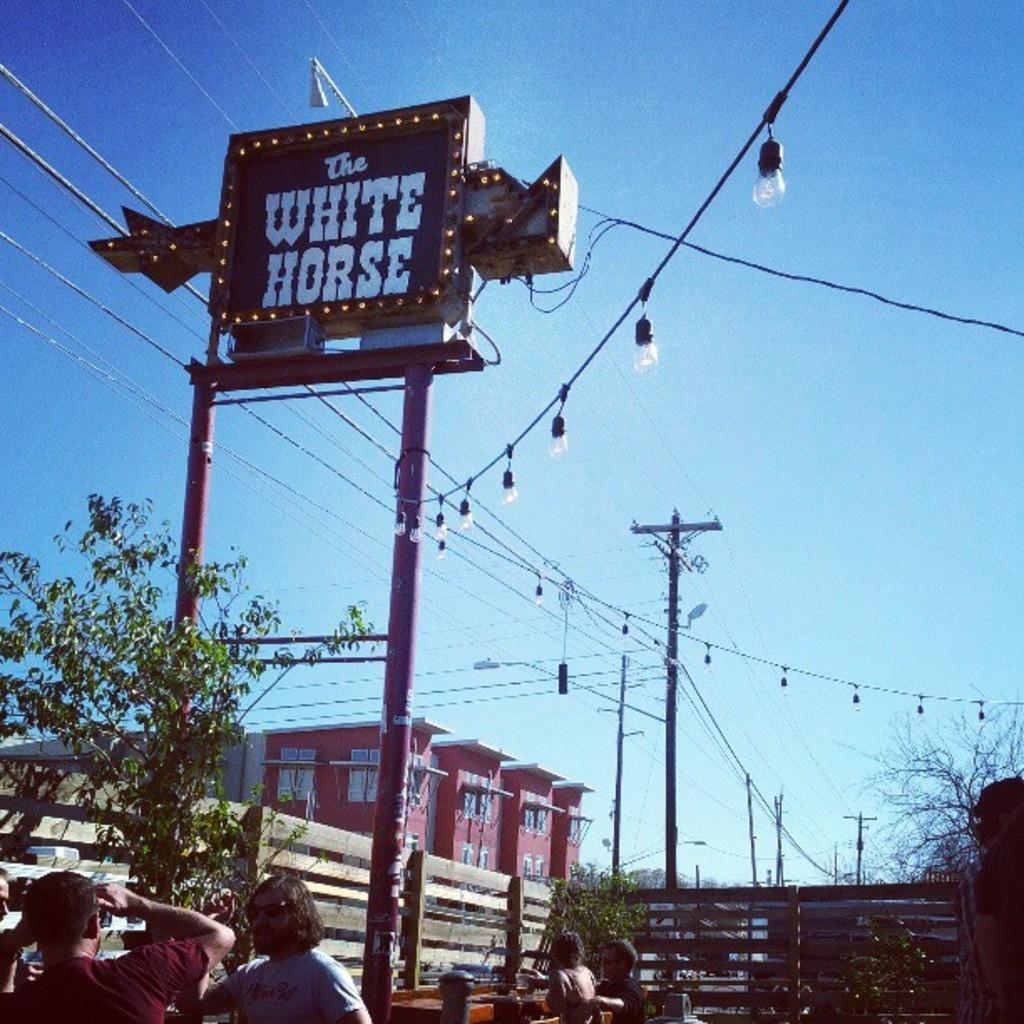How many people are in the group visible in the image? There is a group of people in the image, but the exact number cannot be determined from the provided facts. What type of structure is present in the image? There is a building in the image. What object is present in the image that might be used for displaying information or announcements? There is a board in the image. What type of vertical structures are present in the image? There are poles in the image. What type of illumination is present in the image? There are lights in the image. What type of electrical infrastructure is present in the image? There are cables in the image. What type of natural vegetation is present in the image? There are trees in the image. What can be seen in the background of the image? The sky is visible in the background of the image. How does the ball interact with the group of people in the image? There is no ball present in the image, so it cannot interact with the group of people. Who is the friend that is attacking the building in the image? There is no attack or friend present in the image; it only shows a group of people, a building, a board, poles, lights, cables, trees, and the sky. 